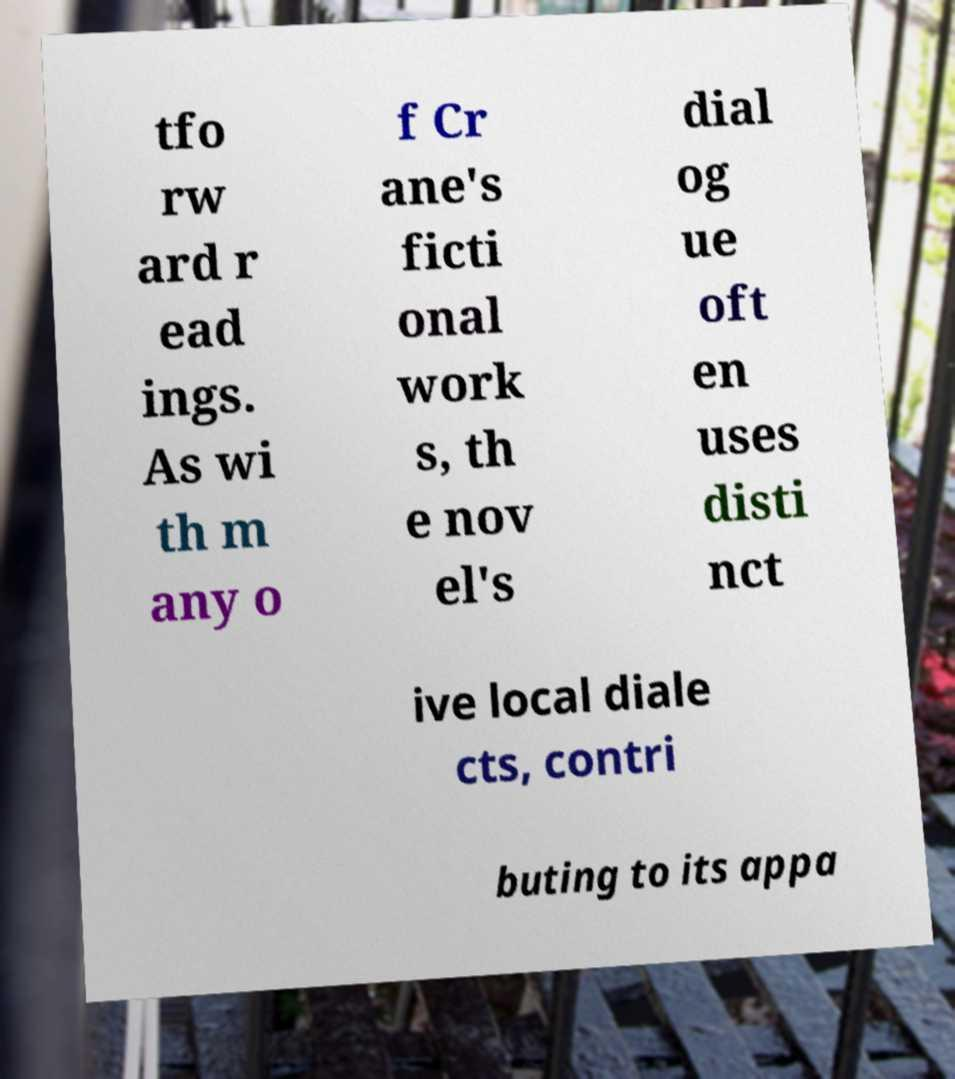Could you assist in decoding the text presented in this image and type it out clearly? tfo rw ard r ead ings. As wi th m any o f Cr ane's ficti onal work s, th e nov el's dial og ue oft en uses disti nct ive local diale cts, contri buting to its appa 